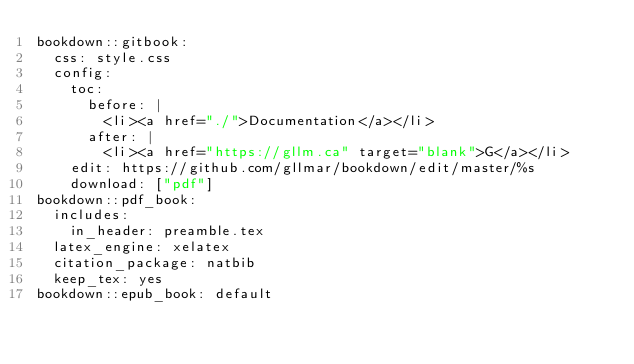<code> <loc_0><loc_0><loc_500><loc_500><_YAML_>bookdown::gitbook:
  css: style.css
  config:
    toc:
      before: |
        <li><a href="./">Documentation</a></li>
      after: |
        <li><a href="https://gllm.ca" target="blank">G</a></li>
    edit: https://github.com/gllmar/bookdown/edit/master/%s
    download: ["pdf"]
bookdown::pdf_book:
  includes:
    in_header: preamble.tex
  latex_engine: xelatex
  citation_package: natbib
  keep_tex: yes
bookdown::epub_book: default
</code> 